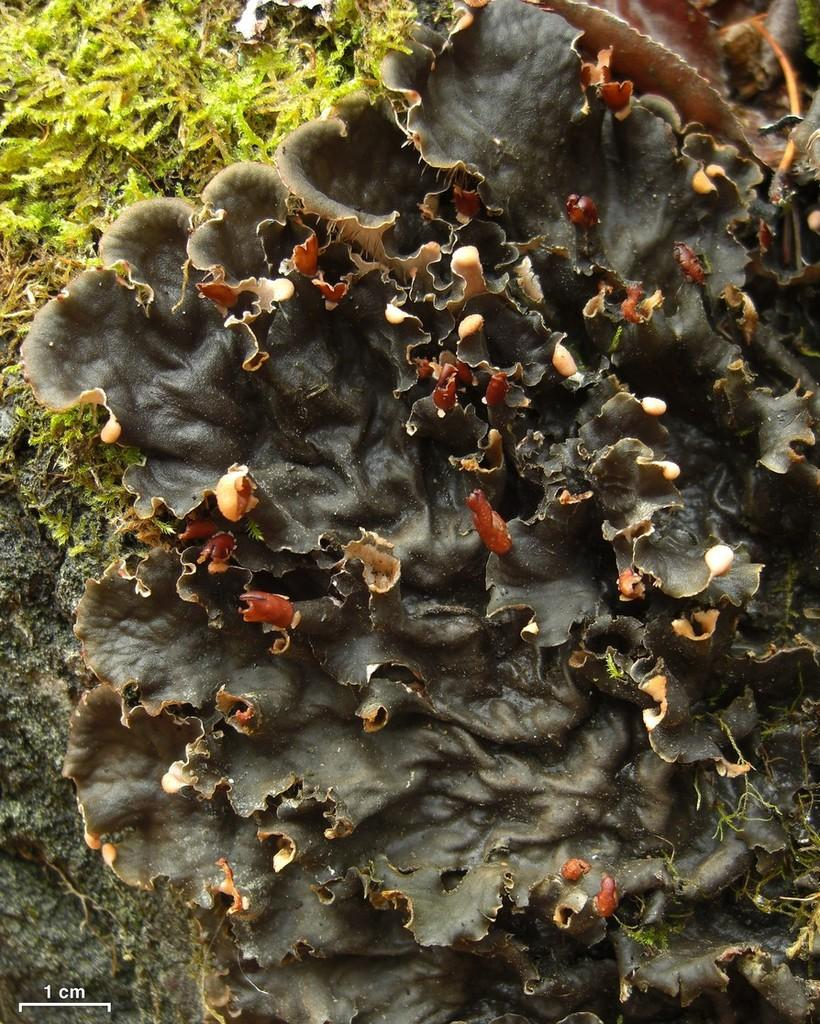What type of plant is visible in the image? There is a plant with leaves in the image. Can you describe the setting of the image? There are other plants on rocks in the background of the image. What type of cherry is being used to improve the acoustics in the image? There is no cherry present in the image, and the image does not depict any acoustic improvements. 